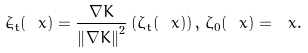Convert formula to latex. <formula><loc_0><loc_0><loc_500><loc_500>\dot { \zeta } _ { t } ( \ x ) = \frac { \nabla K } { \left \| \nabla K \right \| ^ { 2 } } \left ( \zeta _ { t } ( \ x ) \right ) , \, \zeta _ { 0 } ( \ x ) = \ x .</formula> 